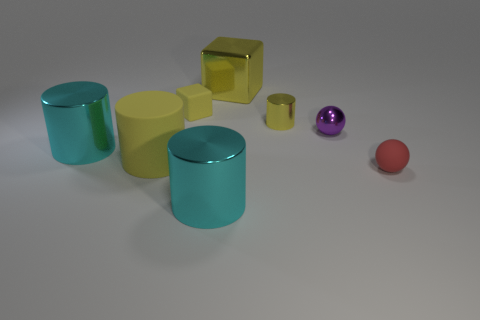Add 1 large matte blocks. How many objects exist? 9 Subtract all cubes. How many objects are left? 6 Add 2 tiny purple metallic balls. How many tiny purple metallic balls exist? 3 Subtract 0 gray cylinders. How many objects are left? 8 Subtract all small brown metallic objects. Subtract all cyan things. How many objects are left? 6 Add 6 tiny yellow matte blocks. How many tiny yellow matte blocks are left? 7 